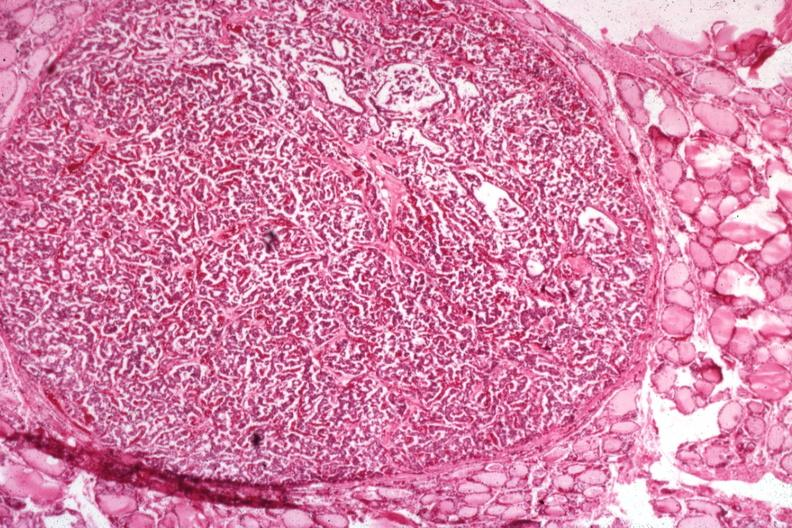where is this part in the figure?
Answer the question using a single word or phrase. Endocrine system 